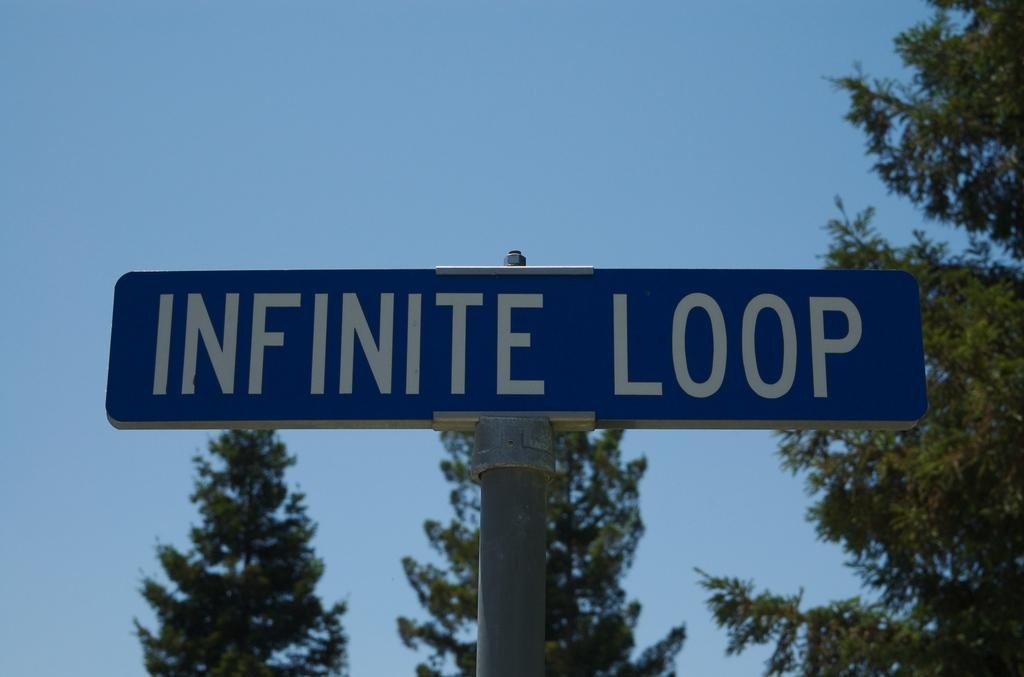What is the main object in the image? There is a sign board in the image. What can be found on the sign board? There is text on the sign board. What type of natural environment is visible in the background of the image? There are trees in the background of the image. What else can be seen in the background of the image? The sky is visible in the background of the image. What type of iron is being used to bake a pie in the image? There is no iron or pie present in the image; it features a sign board with text and a background with trees and the sky. 